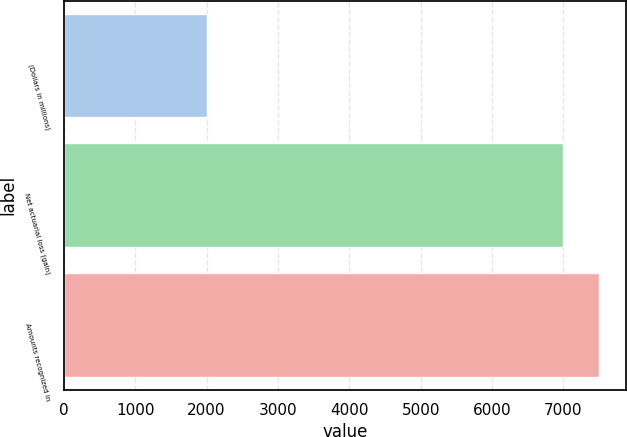<chart> <loc_0><loc_0><loc_500><loc_500><bar_chart><fcel>(Dollars in millions)<fcel>Net actuarial loss (gain)<fcel>Amounts recognized in<nl><fcel>2012<fcel>6998<fcel>7500<nl></chart> 